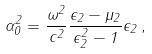<formula> <loc_0><loc_0><loc_500><loc_500>\alpha _ { 0 } ^ { 2 } = \frac { \omega ^ { 2 } } { c ^ { 2 } } \frac { \epsilon _ { 2 } - \mu _ { 2 } } { \epsilon _ { 2 } ^ { 2 } - 1 } \epsilon _ { 2 } \, ,</formula> 